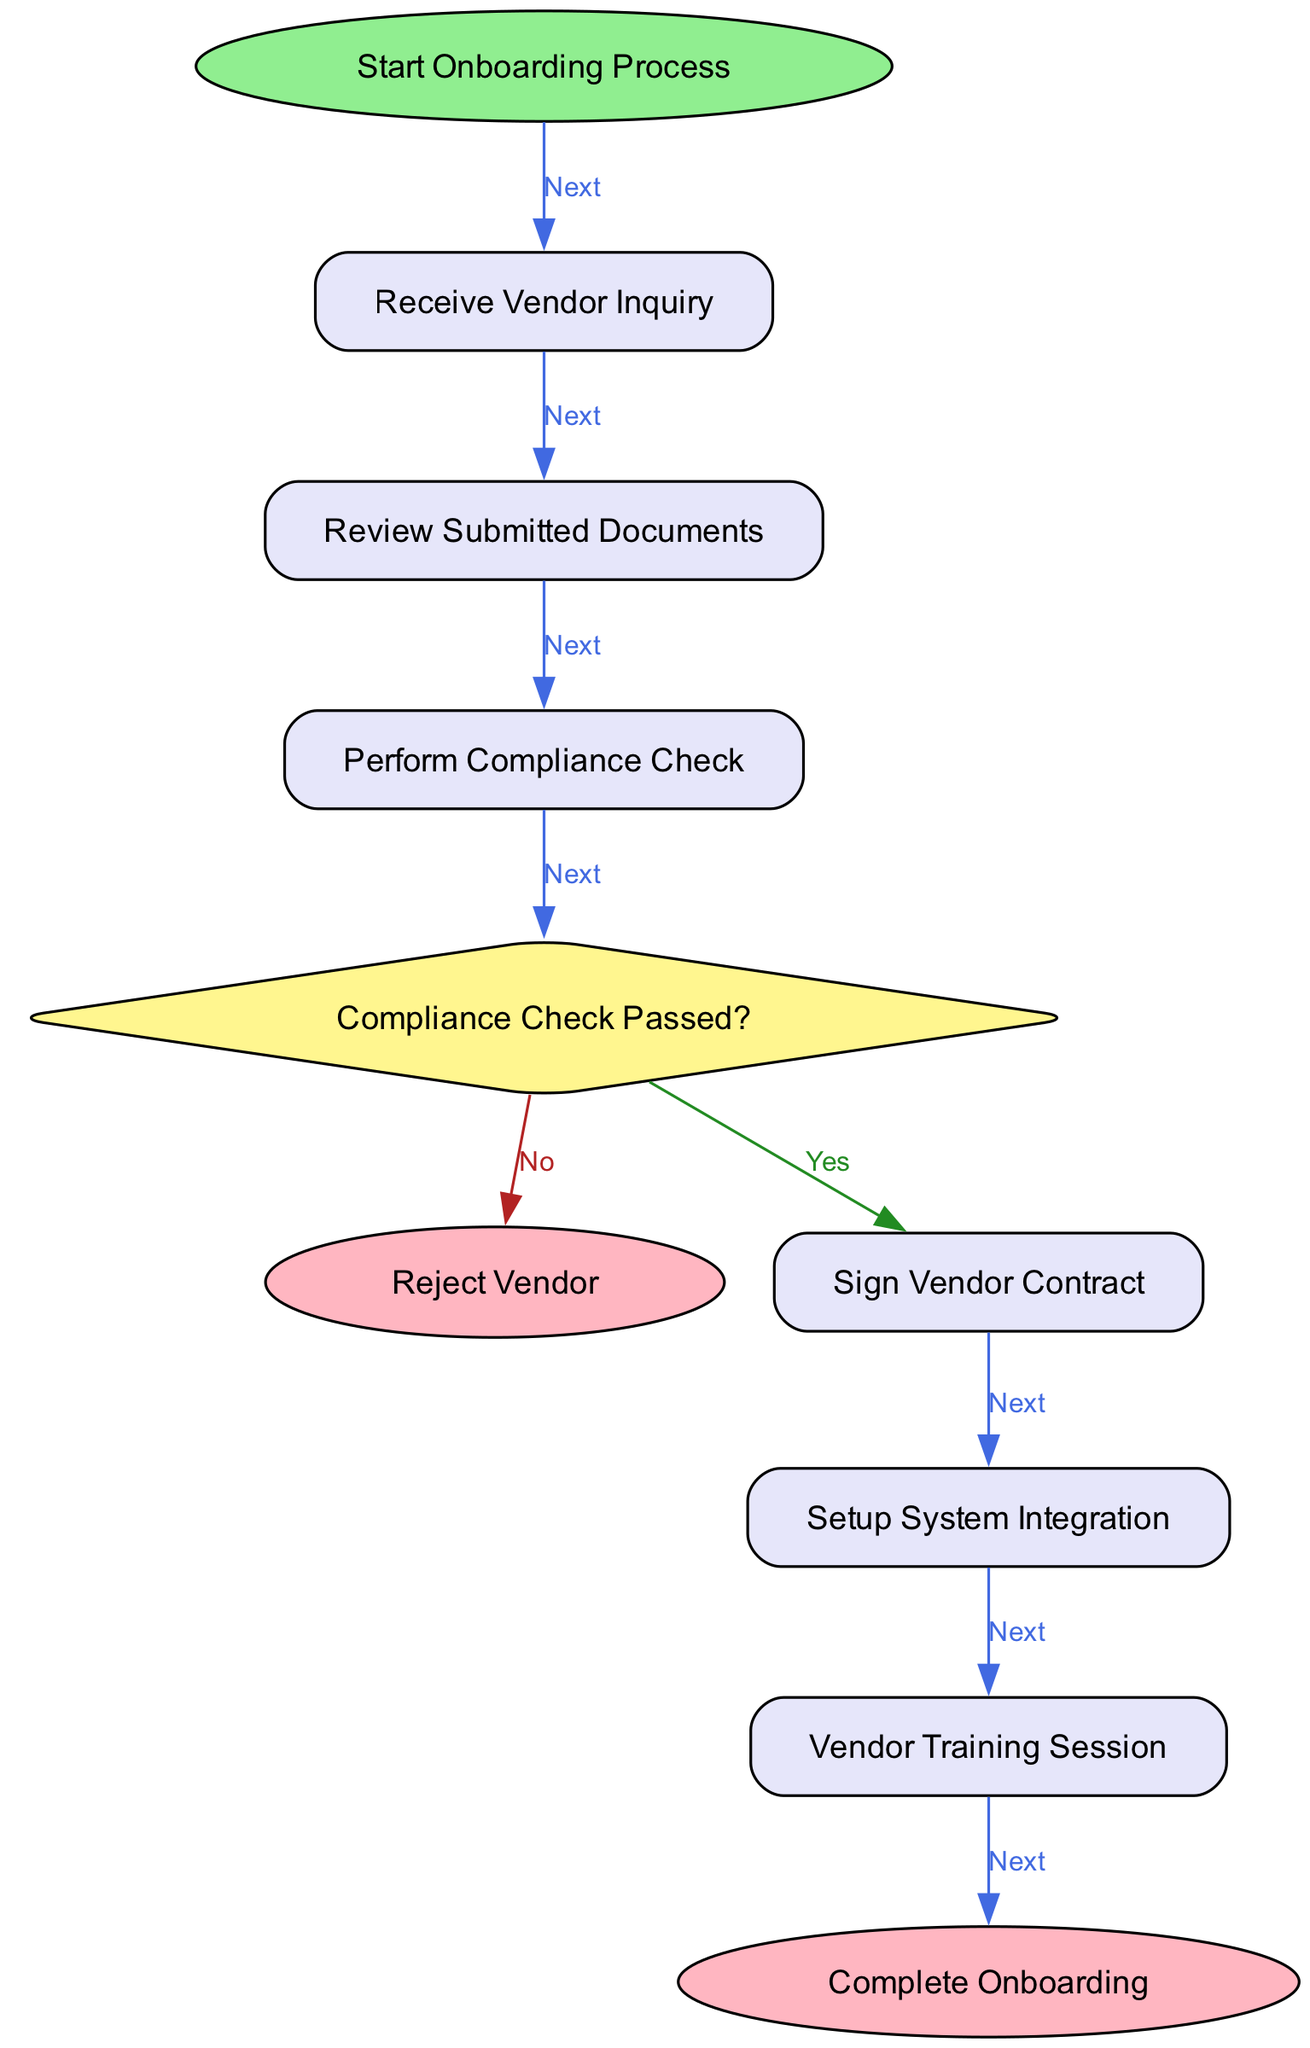What is the first action in the onboarding process? The first node in the diagram is labeled "Start Onboarding Process," which indicates the beginning of the workflow. The edge leading from this node goes to "Receive Vendor Inquiry," confirming that receiving the inquiry is the first action taken.
Answer: Receive Vendor Inquiry How many actions are in the onboarding process? The diagram lists several nodes of the type "action." Counting them, there are five actions: "Receive Vendor Inquiry," "Review Submitted Documents," "Perform Compliance Check," "Sign Vendor Contract," "Setup System Integration," and "Vendor Training Session." Thus, the total number of action nodes is six.
Answer: Six What happens if the compliance check does not pass? According to the diagram, if the compliance check does not pass, the flow leads to the "Reject Vendor" node. This is indicated by the "No" branch of the decision node labeled "Compliance Check Passed?"
Answer: Reject Vendor Which node follows the "Sign Vendor Contract" node? The "Sign Vendor Contract" node has an outgoing edge labeled "Next" that leads to the "Setup System Integration" node, indicating that this is the next step after signing the contract.
Answer: Setup System Integration Is "Reject Vendor" an end node? Yes, "Reject Vendor" is indicated as an end node in the diagram, evidenced by its shape and the lack of outgoing edges, signifying the conclusion of the process if a vendor is not accepted.
Answer: Yes What is the last action before completing the onboarding process? The last action before reaching the "Complete Onboarding" end node is "Vendor Training Session," which is the final action taken to ensure the vendor is prepared to engage effectively.
Answer: Vendor Training Session How many decision points are there in the onboarding workflow? The diagram features one decision node labeled "Compliance Check Passed?" which distinguishes between whether the compliance check was passed or not leading to two possible outcomes. Therefore, there is one decision point.
Answer: One What is the final outcome of a successful vendor onboarding process? The successful conclusion of the process is represented by the node labeled "Complete Onboarding," which signifies that the entire onboarding workflow has been successfully finished.
Answer: Complete Onboarding 